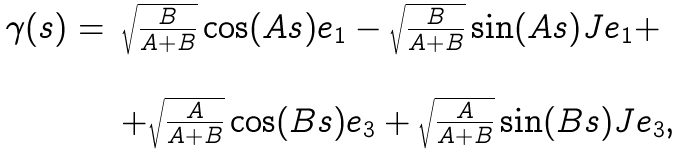Convert formula to latex. <formula><loc_0><loc_0><loc_500><loc_500>\begin{array} { c l } \gamma ( s ) = & \sqrt { \frac { B } { A + B } } \cos ( A s ) e _ { 1 } - \sqrt { \frac { B } { A + B } } \sin ( A s ) J e _ { 1 } + \\ \\ & + \sqrt { \frac { A } { A + B } } \cos ( B s ) e _ { 3 } + \sqrt { \frac { A } { A + B } } \sin ( B s ) J e _ { 3 } , \end{array}</formula> 